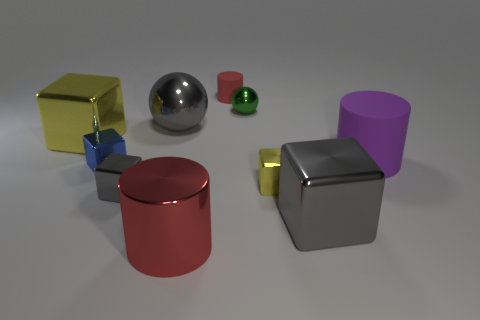How many yellow blocks must be subtracted to get 1 yellow blocks? 1 Subtract all large rubber cylinders. How many cylinders are left? 2 Subtract all gray spheres. How many spheres are left? 1 Subtract 1 cylinders. How many cylinders are left? 2 Subtract all spheres. How many objects are left? 8 Subtract all purple blocks. How many purple spheres are left? 0 Subtract all green metal cylinders. Subtract all small yellow shiny cubes. How many objects are left? 9 Add 5 small yellow blocks. How many small yellow blocks are left? 6 Add 4 small gray metal blocks. How many small gray metal blocks exist? 5 Subtract 0 brown spheres. How many objects are left? 10 